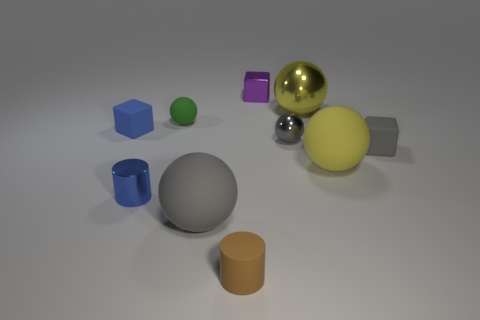Subtract all green balls. How many balls are left? 4 Subtract all tiny gray balls. How many balls are left? 4 Subtract all cyan spheres. Subtract all blue cubes. How many spheres are left? 5 Subtract all blocks. How many objects are left? 7 Subtract all tiny green rubber spheres. Subtract all tiny gray shiny things. How many objects are left? 8 Add 6 tiny blue cylinders. How many tiny blue cylinders are left? 7 Add 3 large cyan cubes. How many large cyan cubes exist? 3 Subtract 0 purple cylinders. How many objects are left? 10 